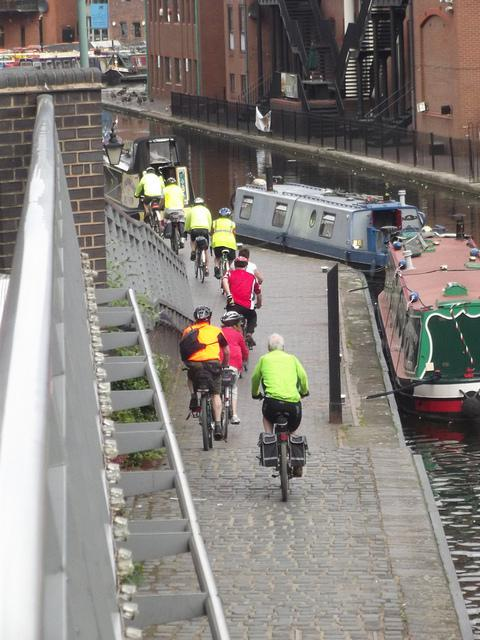Why are some cyclists wearing yellow? Please explain your reasoning. visibility. There are some cyclists wearing the color yellow for additional visibility. 